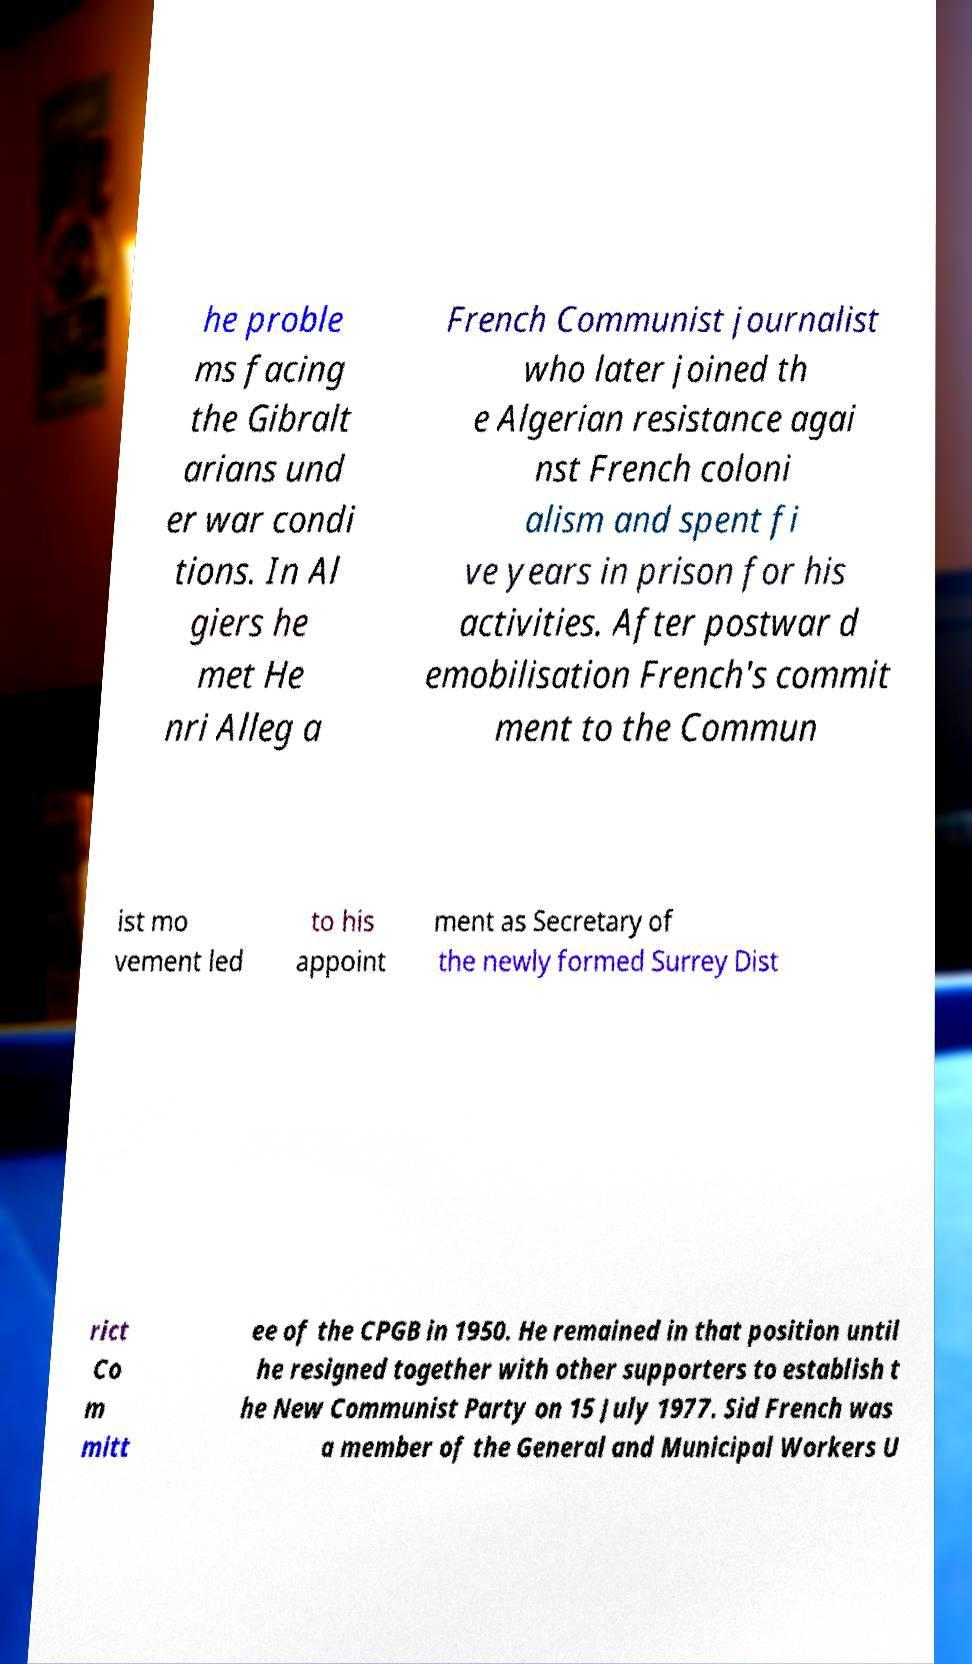Could you extract and type out the text from this image? he proble ms facing the Gibralt arians und er war condi tions. In Al giers he met He nri Alleg a French Communist journalist who later joined th e Algerian resistance agai nst French coloni alism and spent fi ve years in prison for his activities. After postwar d emobilisation French's commit ment to the Commun ist mo vement led to his appoint ment as Secretary of the newly formed Surrey Dist rict Co m mitt ee of the CPGB in 1950. He remained in that position until he resigned together with other supporters to establish t he New Communist Party on 15 July 1977. Sid French was a member of the General and Municipal Workers U 